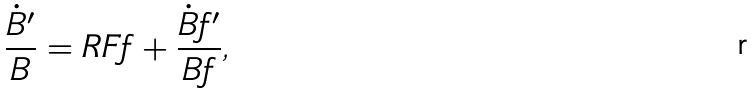<formula> <loc_0><loc_0><loc_500><loc_500>\frac { \dot { B } ^ { \prime } } { B } = R F f + \frac { \dot { B } f ^ { \prime } } { B f } ,</formula> 